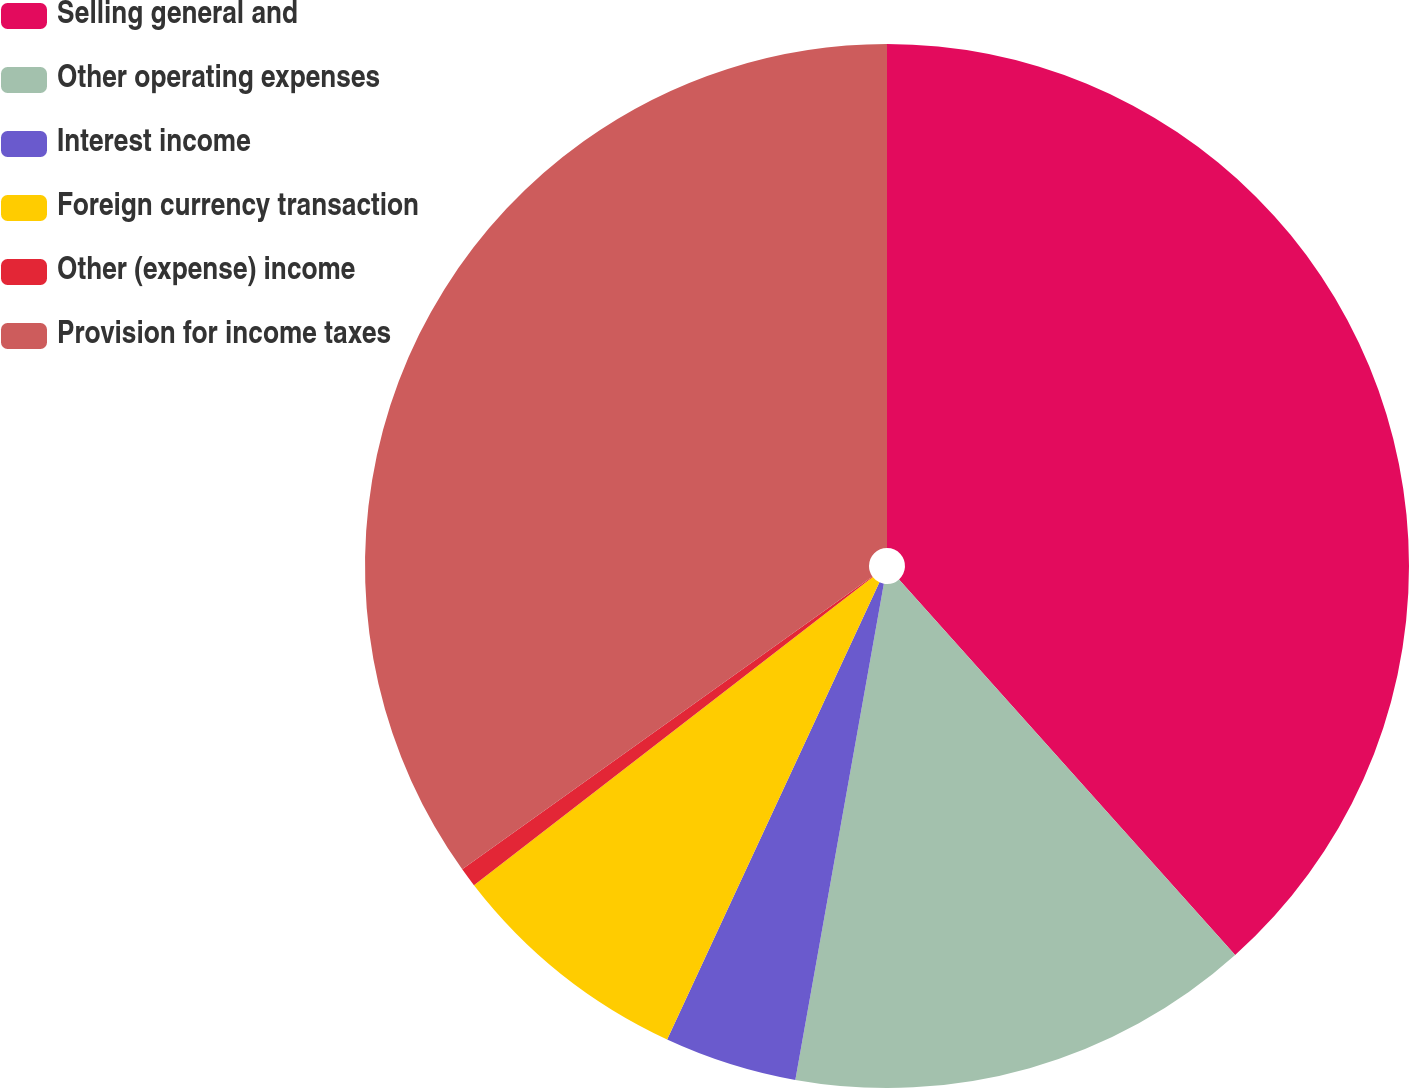<chart> <loc_0><loc_0><loc_500><loc_500><pie_chart><fcel>Selling general and<fcel>Other operating expenses<fcel>Interest income<fcel>Foreign currency transaction<fcel>Other (expense) income<fcel>Provision for income taxes<nl><fcel>38.38%<fcel>14.43%<fcel>4.11%<fcel>7.61%<fcel>0.6%<fcel>34.87%<nl></chart> 